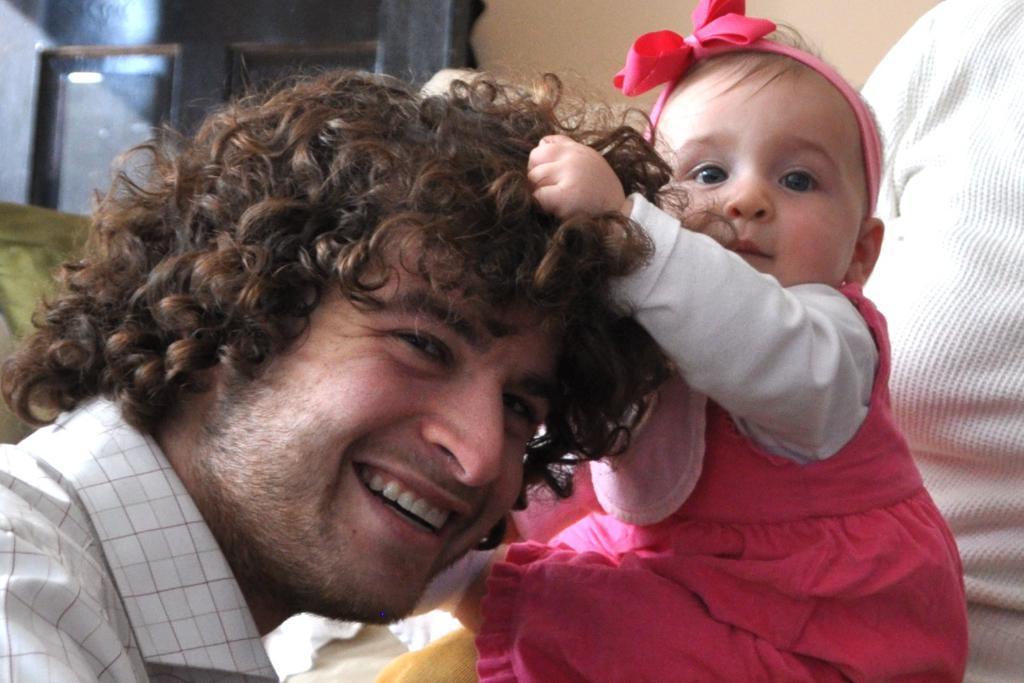Please provide a concise description of this image. In the image on the left side we can see one person smiling,which we can see on his face. On the right side,we can see one person and one baby holding hair. In the background there is a wall,glass and few other objects. 